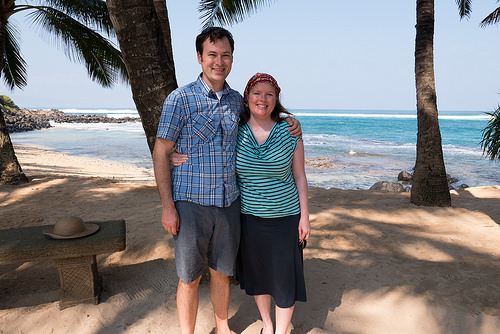<image>
Can you confirm if the water is behind the tree? Yes. From this viewpoint, the water is positioned behind the tree, with the tree partially or fully occluding the water. Is there a cap behind the tree? No. The cap is not behind the tree. From this viewpoint, the cap appears to be positioned elsewhere in the scene. Where is the boy in relation to the girl? Is it next to the girl? Yes. The boy is positioned adjacent to the girl, located nearby in the same general area. 